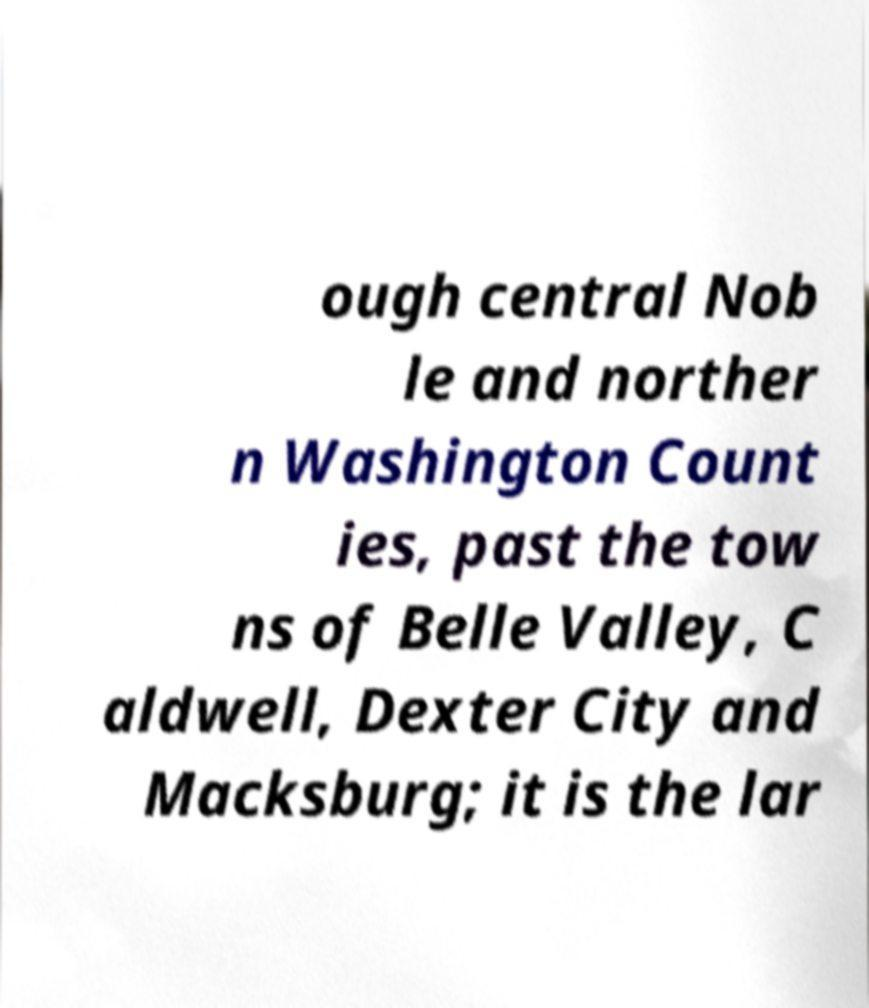Could you assist in decoding the text presented in this image and type it out clearly? ough central Nob le and norther n Washington Count ies, past the tow ns of Belle Valley, C aldwell, Dexter City and Macksburg; it is the lar 